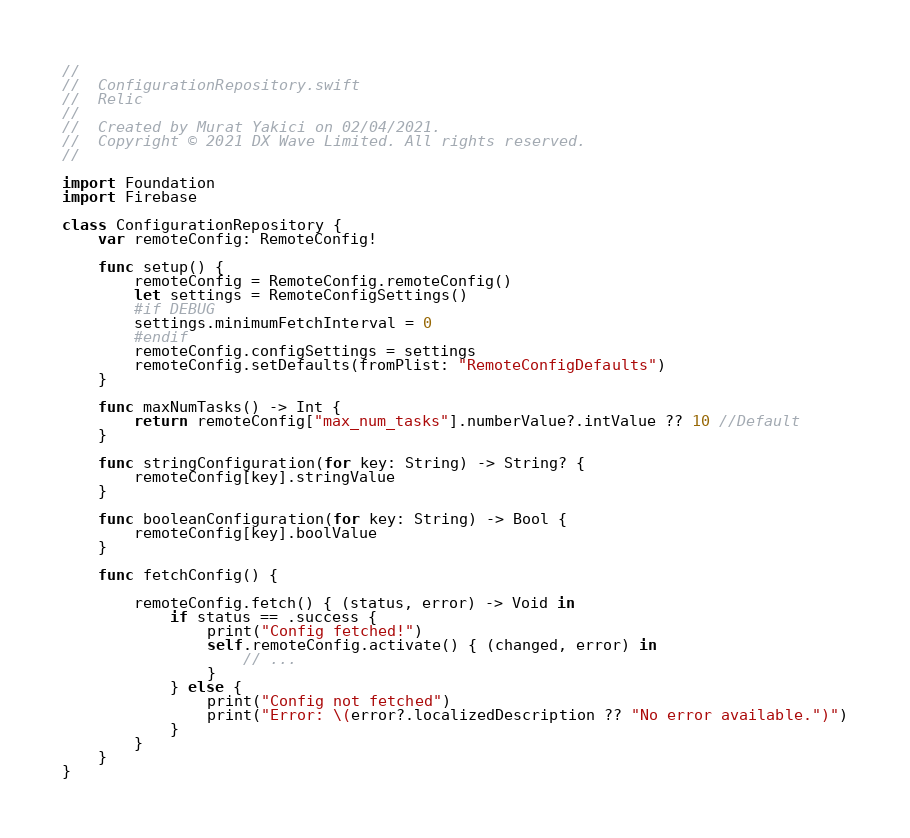<code> <loc_0><loc_0><loc_500><loc_500><_Swift_>//
//  ConfigurationRepository.swift
//  Relic
//
//  Created by Murat Yakici on 02/04/2021.
//  Copyright © 2021 DX Wave Limited. All rights reserved.
//

import Foundation
import Firebase

class ConfigurationRepository {
    var remoteConfig: RemoteConfig!

    func setup() {
        remoteConfig = RemoteConfig.remoteConfig()
        let settings = RemoteConfigSettings()
        #if DEBUG
        settings.minimumFetchInterval = 0
        #endif
        remoteConfig.configSettings = settings
        remoteConfig.setDefaults(fromPlist: "RemoteConfigDefaults")
    }

    func maxNumTasks() -> Int {
        return remoteConfig["max_num_tasks"].numberValue?.intValue ?? 10 //Default
    }

    func stringConfiguration(for key: String) -> String? {
        remoteConfig[key].stringValue
    }

    func booleanConfiguration(for key: String) -> Bool {
        remoteConfig[key].boolValue
    }

    func fetchConfig() {

        remoteConfig.fetch() { (status, error) -> Void in
            if status == .success {
                print("Config fetched!")
                self.remoteConfig.activate() { (changed, error) in
                    // ...
                }
            } else {
                print("Config not fetched")
                print("Error: \(error?.localizedDescription ?? "No error available.")")
            }
        }
    }
}
</code> 